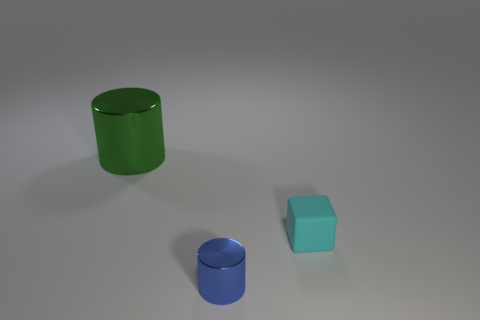There is a metal object that is in front of the matte cube; does it have the same shape as the green shiny thing?
Your response must be concise. Yes. There is a cylinder that is the same size as the cyan rubber cube; what material is it?
Give a very brief answer. Metal. Are there any other big cylinders made of the same material as the blue cylinder?
Keep it short and to the point. Yes. Do the cyan thing and the shiny thing on the right side of the green cylinder have the same shape?
Provide a short and direct response. No. How many things are on the left side of the tiny cyan matte object and in front of the large cylinder?
Keep it short and to the point. 1. Do the small cyan block and the cylinder that is behind the tiny matte block have the same material?
Keep it short and to the point. No. Is the number of big green shiny things that are behind the large thing the same as the number of large cyan cylinders?
Your answer should be compact. Yes. There is a cylinder that is behind the blue cylinder; what color is it?
Your response must be concise. Green. How many other objects are the same color as the block?
Provide a succinct answer. 0. Are there any other things that have the same size as the green object?
Provide a succinct answer. No. 